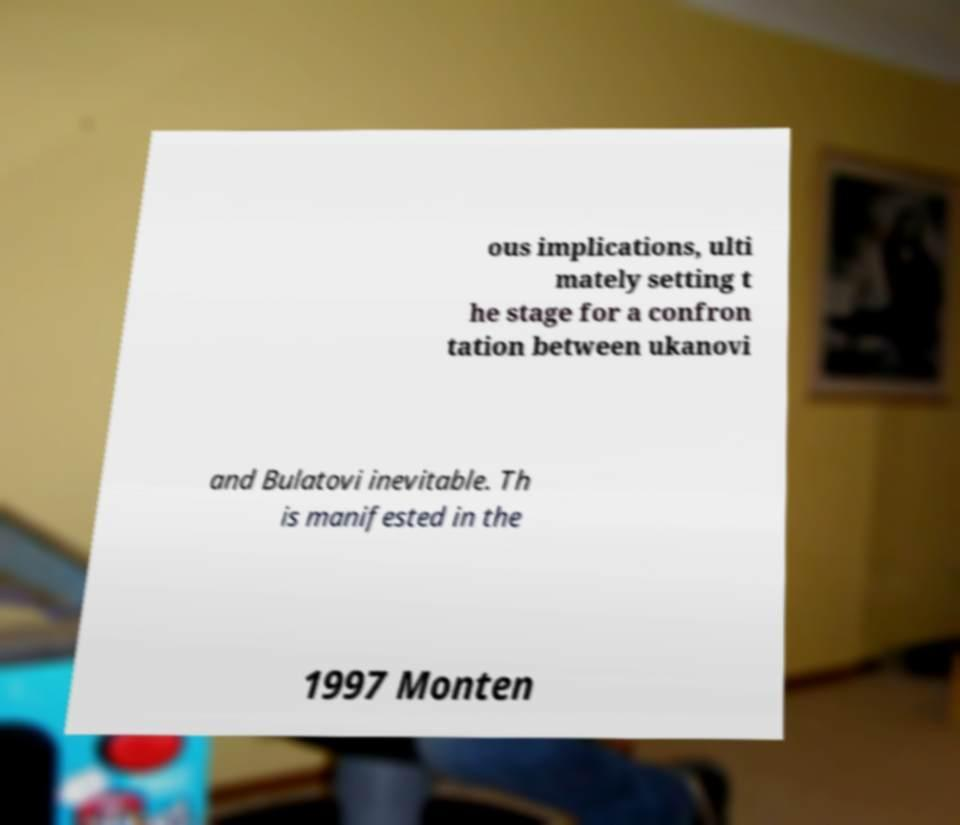Can you accurately transcribe the text from the provided image for me? ous implications, ulti mately setting t he stage for a confron tation between ukanovi and Bulatovi inevitable. Th is manifested in the 1997 Monten 